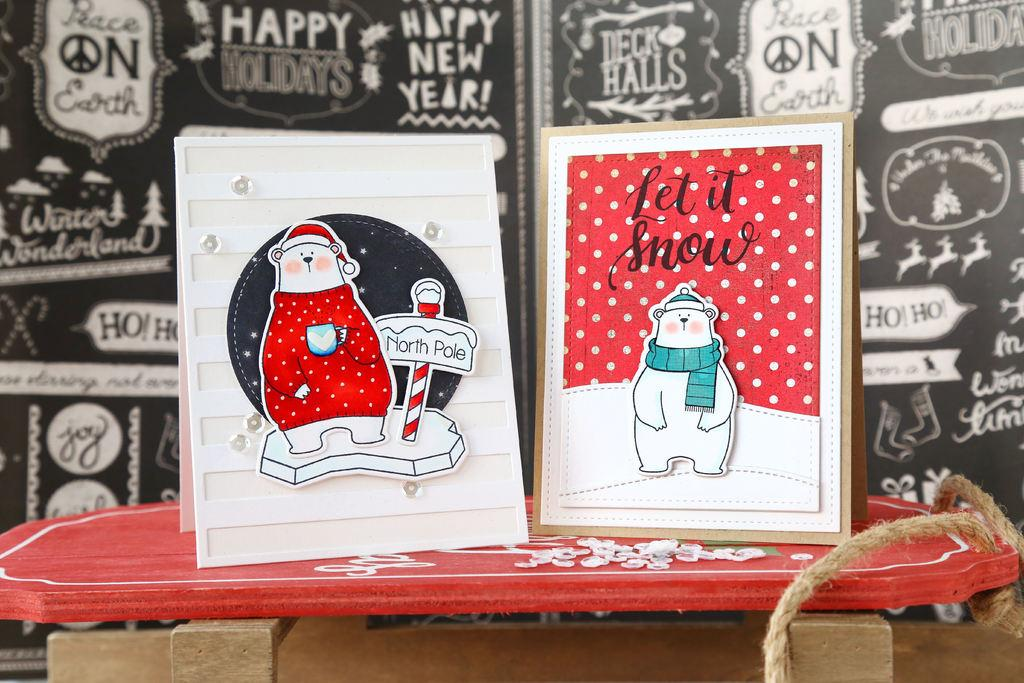What is the main object in the center of the image? There is a table in the center of the image. What can be found on the table? Frames and rope are visible on the table. Can you describe one of the frames? One of the frames has the text "Let It Snow" written on it. What is visible in the background of the image? There is a banner in the background of the image. How many sticks are being used to hold up the alley in the image? There are no sticks or alleys present in the image. What type of muscle is being exercised by the person in the image? There is no person present in the image, so it is not possible to determine which muscles are being exercised. 